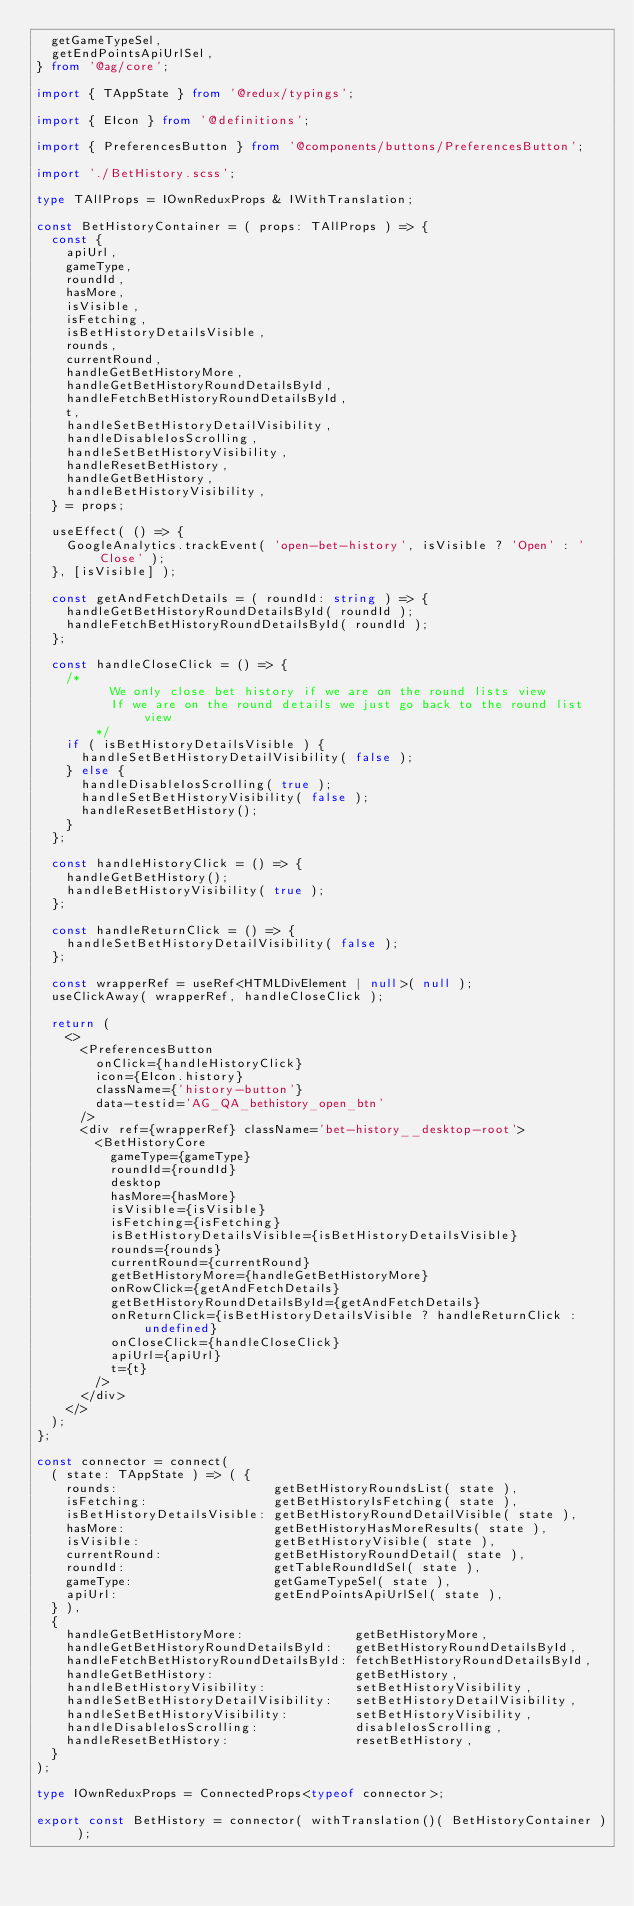Convert code to text. <code><loc_0><loc_0><loc_500><loc_500><_TypeScript_>  getGameTypeSel,
  getEndPointsApiUrlSel,
} from '@ag/core';

import { TAppState } from '@redux/typings';

import { EIcon } from '@definitions';

import { PreferencesButton } from '@components/buttons/PreferencesButton';

import './BetHistory.scss';

type TAllProps = IOwnReduxProps & IWithTranslation;

const BetHistoryContainer = ( props: TAllProps ) => {
  const {
    apiUrl,
    gameType,
    roundId,
    hasMore,
    isVisible,
    isFetching,
    isBetHistoryDetailsVisible,
    rounds,
    currentRound,
    handleGetBetHistoryMore,
    handleGetBetHistoryRoundDetailsById,
    handleFetchBetHistoryRoundDetailsById,
    t,
    handleSetBetHistoryDetailVisibility,
    handleDisableIosScrolling,
    handleSetBetHistoryVisibility,
    handleResetBetHistory,
    handleGetBetHistory,
    handleBetHistoryVisibility,
  } = props;

  useEffect( () => {
    GoogleAnalytics.trackEvent( 'open-bet-history', isVisible ? 'Open' : 'Close' );
  }, [isVisible] );

  const getAndFetchDetails = ( roundId: string ) => {
    handleGetBetHistoryRoundDetailsById( roundId );
    handleFetchBetHistoryRoundDetailsById( roundId );
  };

  const handleCloseClick = () => {
    /*
          We only close bet history if we are on the round lists view
          If we are on the round details we just go back to the round list view
        */
    if ( isBetHistoryDetailsVisible ) {
      handleSetBetHistoryDetailVisibility( false );
    } else {
      handleDisableIosScrolling( true );
      handleSetBetHistoryVisibility( false );
      handleResetBetHistory();
    }
  };

  const handleHistoryClick = () => {
    handleGetBetHistory();
    handleBetHistoryVisibility( true );
  };

  const handleReturnClick = () => {
    handleSetBetHistoryDetailVisibility( false );
  };

  const wrapperRef = useRef<HTMLDivElement | null>( null );
  useClickAway( wrapperRef, handleCloseClick );

  return (
    <>
      <PreferencesButton
        onClick={handleHistoryClick}
        icon={EIcon.history}
        className={'history-button'}
        data-testid='AG_QA_bethistory_open_btn'
      />
      <div ref={wrapperRef} className='bet-history__desktop-root'>
        <BetHistoryCore
          gameType={gameType}
          roundId={roundId}
          desktop
          hasMore={hasMore}
          isVisible={isVisible}
          isFetching={isFetching}
          isBetHistoryDetailsVisible={isBetHistoryDetailsVisible}
          rounds={rounds}
          currentRound={currentRound}
          getBetHistoryMore={handleGetBetHistoryMore}
          onRowClick={getAndFetchDetails}
          getBetHistoryRoundDetailsById={getAndFetchDetails}
          onReturnClick={isBetHistoryDetailsVisible ? handleReturnClick : undefined}
          onCloseClick={handleCloseClick}
          apiUrl={apiUrl}
          t={t}
        />
      </div>
    </>
  );
};

const connector = connect(
  ( state: TAppState ) => ( {
    rounds:                     getBetHistoryRoundsList( state ),
    isFetching:                 getBetHistoryIsFetching( state ),
    isBetHistoryDetailsVisible: getBetHistoryRoundDetailVisible( state ),
    hasMore:                    getBetHistoryHasMoreResults( state ),
    isVisible:                  getBetHistoryVisible( state ),
    currentRound:               getBetHistoryRoundDetail( state ),
    roundId:                    getTableRoundIdSel( state ),
    gameType:                   getGameTypeSel( state ),
    apiUrl:                     getEndPointsApiUrlSel( state ),
  } ),
  {
    handleGetBetHistoryMore:               getBetHistoryMore,
    handleGetBetHistoryRoundDetailsById:   getBetHistoryRoundDetailsById,
    handleFetchBetHistoryRoundDetailsById: fetchBetHistoryRoundDetailsById,
    handleGetBetHistory:                   getBetHistory,
    handleBetHistoryVisibility:            setBetHistoryVisibility,
    handleSetBetHistoryDetailVisibility:   setBetHistoryDetailVisibility,
    handleSetBetHistoryVisibility:         setBetHistoryVisibility,
    handleDisableIosScrolling:             disableIosScrolling,
    handleResetBetHistory:                 resetBetHistory,
  }
);

type IOwnReduxProps = ConnectedProps<typeof connector>;

export const BetHistory = connector( withTranslation()( BetHistoryContainer ) );
</code> 